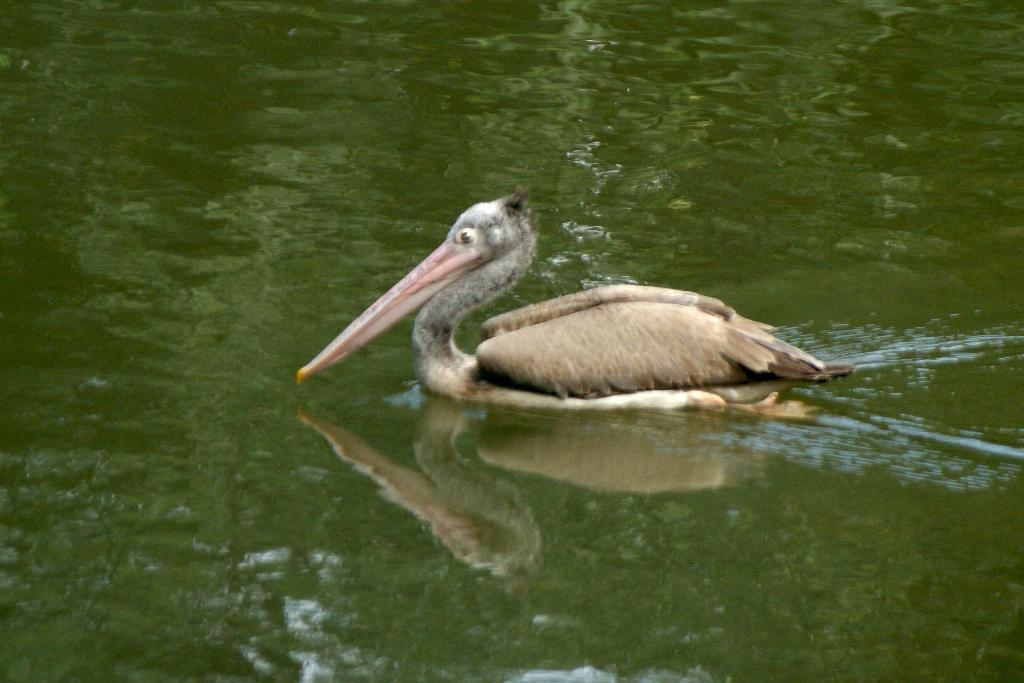What is the main subject in the center of the image? There is a bird in the center of the image. What can be seen at the bottom of the image? There is a river at the bottom of the image. What type of root can be seen growing near the bird in the image? There is no root visible in the image; it only features a bird and a river. 